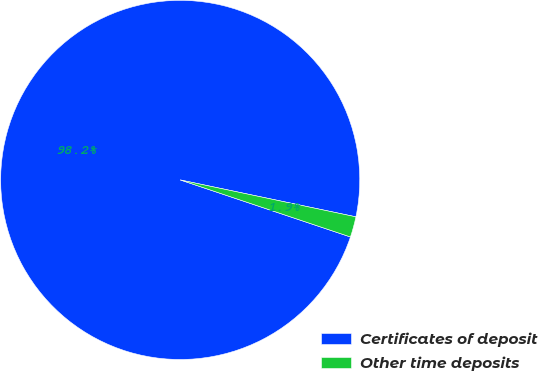Convert chart. <chart><loc_0><loc_0><loc_500><loc_500><pie_chart><fcel>Certificates of deposit<fcel>Other time deposits<nl><fcel>98.15%<fcel>1.85%<nl></chart> 